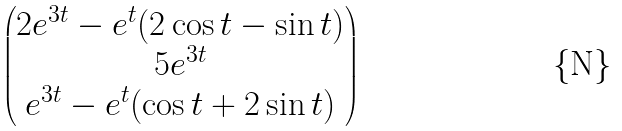Convert formula to latex. <formula><loc_0><loc_0><loc_500><loc_500>\begin{pmatrix} 2 e ^ { 3 t } - e ^ { t } ( 2 \cos { t } - \sin { t } ) \\ 5 e ^ { 3 t } \\ e ^ { 3 t } - e ^ { t } ( \cos { t } + 2 \sin { t } ) \end{pmatrix}</formula> 